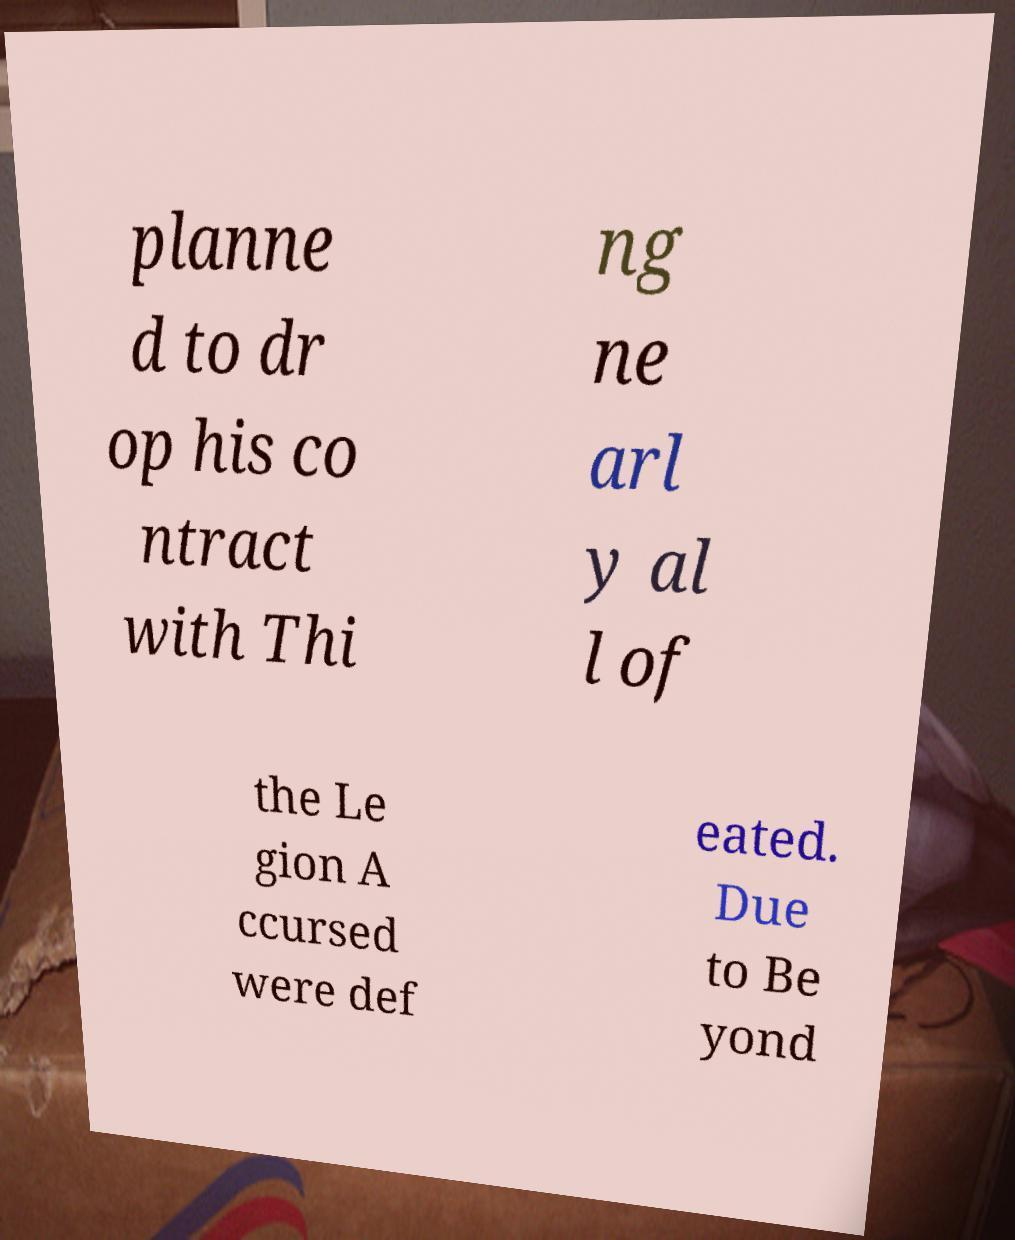There's text embedded in this image that I need extracted. Can you transcribe it verbatim? planne d to dr op his co ntract with Thi ng ne arl y al l of the Le gion A ccursed were def eated. Due to Be yond 